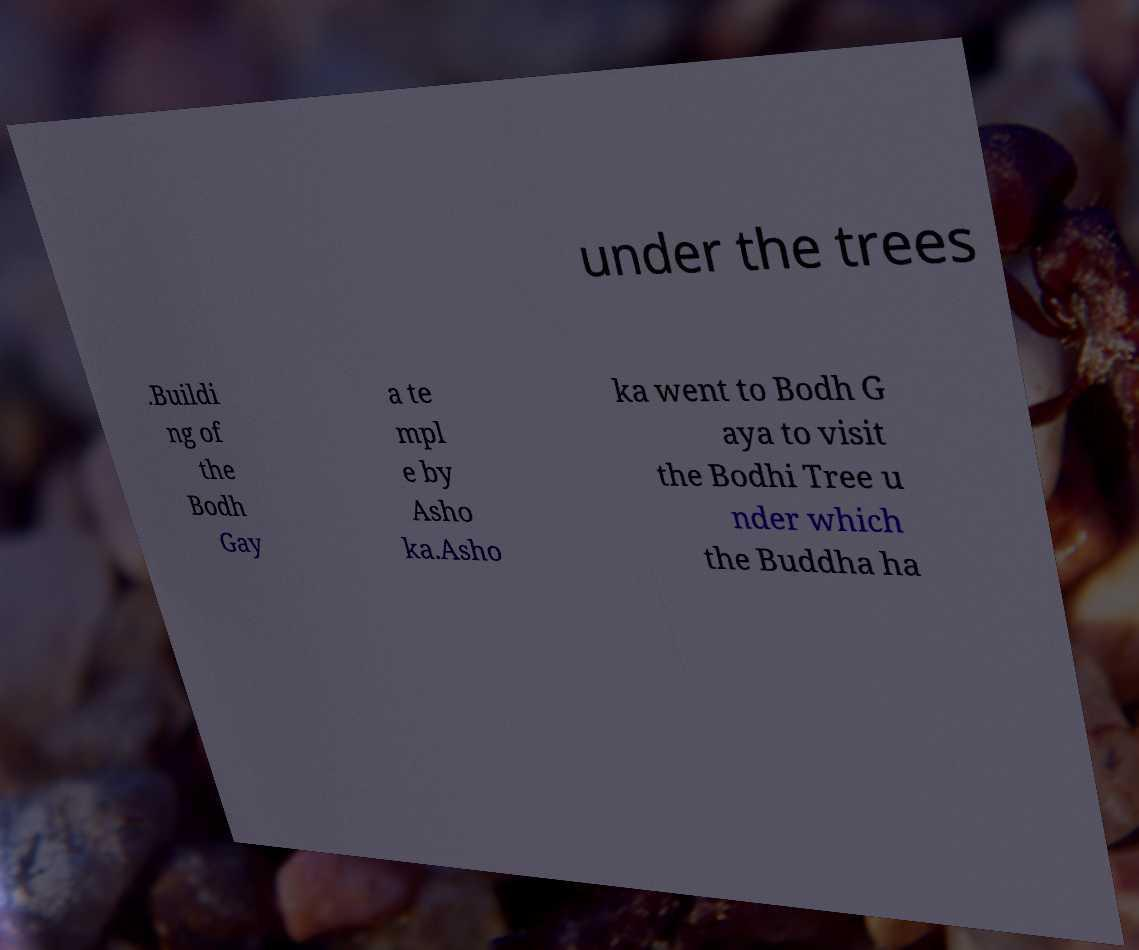I need the written content from this picture converted into text. Can you do that? under the trees .Buildi ng of the Bodh Gay a te mpl e by Asho ka.Asho ka went to Bodh G aya to visit the Bodhi Tree u nder which the Buddha ha 